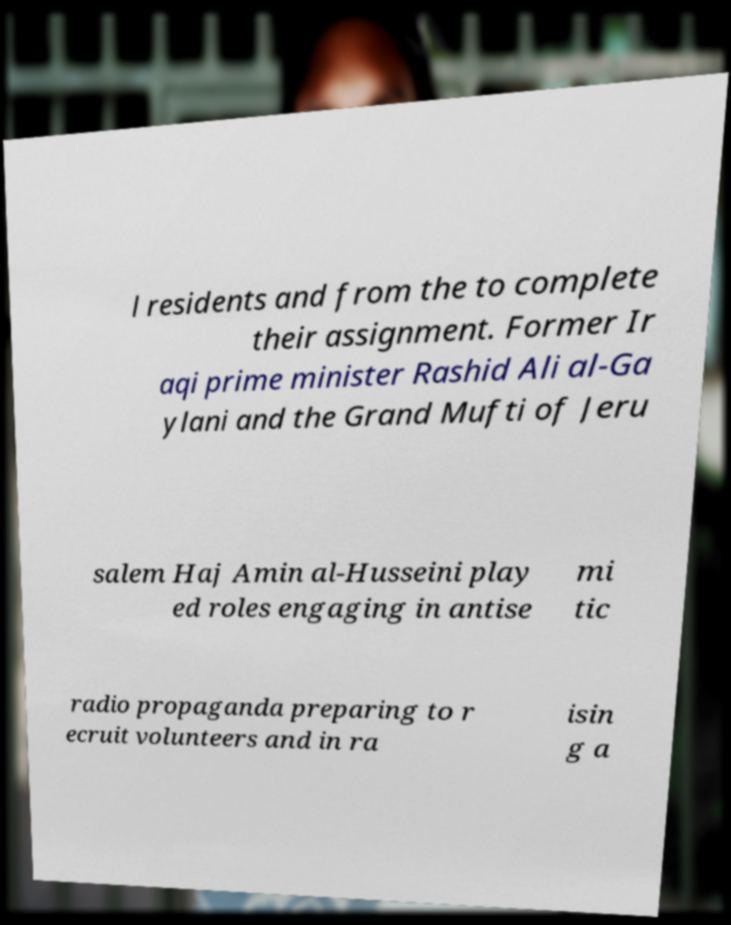Can you accurately transcribe the text from the provided image for me? l residents and from the to complete their assignment. Former Ir aqi prime minister Rashid Ali al-Ga ylani and the Grand Mufti of Jeru salem Haj Amin al-Husseini play ed roles engaging in antise mi tic radio propaganda preparing to r ecruit volunteers and in ra isin g a 